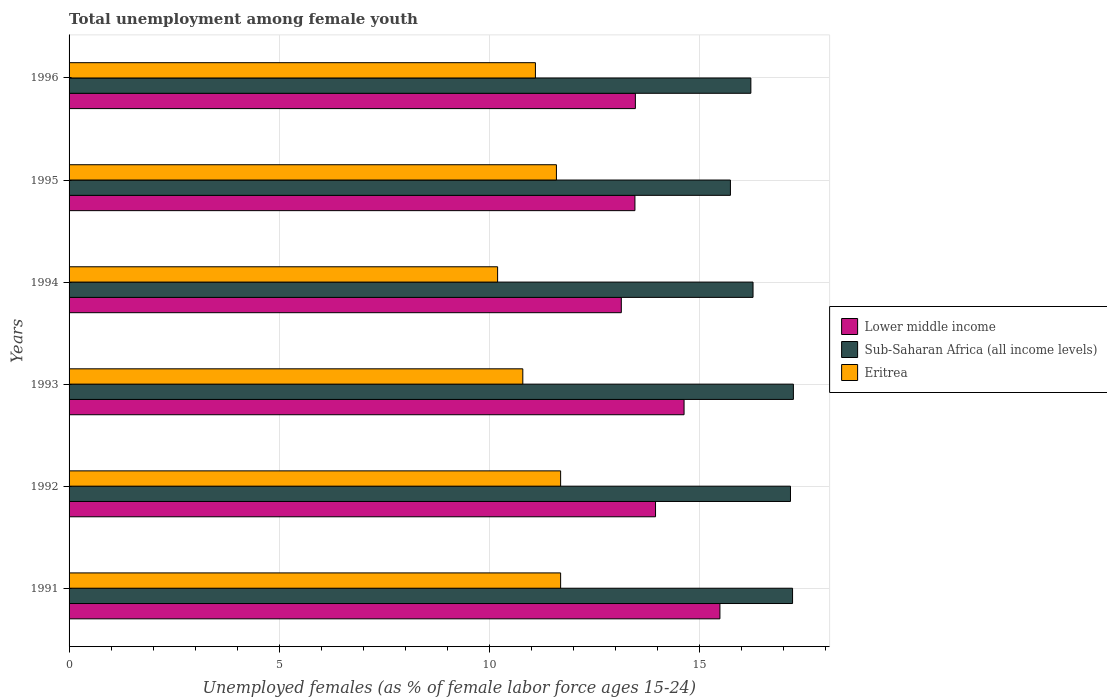How many different coloured bars are there?
Ensure brevity in your answer.  3. How many groups of bars are there?
Make the answer very short. 6. Are the number of bars on each tick of the Y-axis equal?
Provide a succinct answer. Yes. How many bars are there on the 1st tick from the top?
Ensure brevity in your answer.  3. How many bars are there on the 5th tick from the bottom?
Your response must be concise. 3. What is the label of the 4th group of bars from the top?
Offer a terse response. 1993. What is the percentage of unemployed females in in Lower middle income in 1992?
Keep it short and to the point. 13.96. Across all years, what is the maximum percentage of unemployed females in in Eritrea?
Offer a terse response. 11.7. Across all years, what is the minimum percentage of unemployed females in in Eritrea?
Your answer should be very brief. 10.2. In which year was the percentage of unemployed females in in Lower middle income maximum?
Keep it short and to the point. 1991. In which year was the percentage of unemployed females in in Eritrea minimum?
Make the answer very short. 1994. What is the total percentage of unemployed females in in Sub-Saharan Africa (all income levels) in the graph?
Your answer should be compact. 99.88. What is the difference between the percentage of unemployed females in in Eritrea in 1991 and that in 1992?
Offer a terse response. 0. What is the difference between the percentage of unemployed females in in Sub-Saharan Africa (all income levels) in 1993 and the percentage of unemployed females in in Lower middle income in 1992?
Provide a succinct answer. 3.28. What is the average percentage of unemployed females in in Eritrea per year?
Your answer should be compact. 11.18. In the year 1996, what is the difference between the percentage of unemployed females in in Eritrea and percentage of unemployed females in in Lower middle income?
Keep it short and to the point. -2.38. What is the ratio of the percentage of unemployed females in in Lower middle income in 1991 to that in 1994?
Give a very brief answer. 1.18. What is the difference between the highest and the second highest percentage of unemployed females in in Sub-Saharan Africa (all income levels)?
Ensure brevity in your answer.  0.02. What is the difference between the highest and the lowest percentage of unemployed females in in Sub-Saharan Africa (all income levels)?
Offer a terse response. 1.5. What does the 1st bar from the top in 1992 represents?
Offer a very short reply. Eritrea. What does the 1st bar from the bottom in 1992 represents?
Provide a short and direct response. Lower middle income. Is it the case that in every year, the sum of the percentage of unemployed females in in Eritrea and percentage of unemployed females in in Lower middle income is greater than the percentage of unemployed females in in Sub-Saharan Africa (all income levels)?
Offer a very short reply. Yes. How many bars are there?
Provide a short and direct response. 18. Are all the bars in the graph horizontal?
Make the answer very short. Yes. How many years are there in the graph?
Make the answer very short. 6. What is the difference between two consecutive major ticks on the X-axis?
Offer a terse response. 5. Does the graph contain any zero values?
Keep it short and to the point. No. How are the legend labels stacked?
Your response must be concise. Vertical. What is the title of the graph?
Ensure brevity in your answer.  Total unemployment among female youth. What is the label or title of the X-axis?
Give a very brief answer. Unemployed females (as % of female labor force ages 15-24). What is the Unemployed females (as % of female labor force ages 15-24) in Lower middle income in 1991?
Offer a very short reply. 15.49. What is the Unemployed females (as % of female labor force ages 15-24) of Sub-Saharan Africa (all income levels) in 1991?
Give a very brief answer. 17.22. What is the Unemployed females (as % of female labor force ages 15-24) of Eritrea in 1991?
Make the answer very short. 11.7. What is the Unemployed females (as % of female labor force ages 15-24) in Lower middle income in 1992?
Provide a short and direct response. 13.96. What is the Unemployed females (as % of female labor force ages 15-24) in Sub-Saharan Africa (all income levels) in 1992?
Your answer should be very brief. 17.17. What is the Unemployed females (as % of female labor force ages 15-24) in Eritrea in 1992?
Provide a short and direct response. 11.7. What is the Unemployed females (as % of female labor force ages 15-24) of Lower middle income in 1993?
Provide a short and direct response. 14.64. What is the Unemployed females (as % of female labor force ages 15-24) in Sub-Saharan Africa (all income levels) in 1993?
Make the answer very short. 17.24. What is the Unemployed females (as % of female labor force ages 15-24) of Eritrea in 1993?
Your answer should be very brief. 10.8. What is the Unemployed females (as % of female labor force ages 15-24) of Lower middle income in 1994?
Make the answer very short. 13.14. What is the Unemployed females (as % of female labor force ages 15-24) in Sub-Saharan Africa (all income levels) in 1994?
Make the answer very short. 16.28. What is the Unemployed females (as % of female labor force ages 15-24) of Eritrea in 1994?
Your answer should be very brief. 10.2. What is the Unemployed females (as % of female labor force ages 15-24) in Lower middle income in 1995?
Your response must be concise. 13.47. What is the Unemployed females (as % of female labor force ages 15-24) of Sub-Saharan Africa (all income levels) in 1995?
Your response must be concise. 15.74. What is the Unemployed females (as % of female labor force ages 15-24) of Eritrea in 1995?
Keep it short and to the point. 11.6. What is the Unemployed females (as % of female labor force ages 15-24) in Lower middle income in 1996?
Your answer should be very brief. 13.48. What is the Unemployed females (as % of female labor force ages 15-24) in Sub-Saharan Africa (all income levels) in 1996?
Provide a succinct answer. 16.23. What is the Unemployed females (as % of female labor force ages 15-24) in Eritrea in 1996?
Ensure brevity in your answer.  11.1. Across all years, what is the maximum Unemployed females (as % of female labor force ages 15-24) in Lower middle income?
Keep it short and to the point. 15.49. Across all years, what is the maximum Unemployed females (as % of female labor force ages 15-24) in Sub-Saharan Africa (all income levels)?
Give a very brief answer. 17.24. Across all years, what is the maximum Unemployed females (as % of female labor force ages 15-24) of Eritrea?
Offer a very short reply. 11.7. Across all years, what is the minimum Unemployed females (as % of female labor force ages 15-24) in Lower middle income?
Offer a terse response. 13.14. Across all years, what is the minimum Unemployed females (as % of female labor force ages 15-24) of Sub-Saharan Africa (all income levels)?
Offer a very short reply. 15.74. Across all years, what is the minimum Unemployed females (as % of female labor force ages 15-24) in Eritrea?
Offer a terse response. 10.2. What is the total Unemployed females (as % of female labor force ages 15-24) in Lower middle income in the graph?
Give a very brief answer. 84.18. What is the total Unemployed females (as % of female labor force ages 15-24) of Sub-Saharan Africa (all income levels) in the graph?
Your answer should be compact. 99.88. What is the total Unemployed females (as % of female labor force ages 15-24) in Eritrea in the graph?
Offer a very short reply. 67.1. What is the difference between the Unemployed females (as % of female labor force ages 15-24) in Lower middle income in 1991 and that in 1992?
Keep it short and to the point. 1.53. What is the difference between the Unemployed females (as % of female labor force ages 15-24) of Sub-Saharan Africa (all income levels) in 1991 and that in 1992?
Give a very brief answer. 0.05. What is the difference between the Unemployed females (as % of female labor force ages 15-24) in Lower middle income in 1991 and that in 1993?
Your answer should be very brief. 0.85. What is the difference between the Unemployed females (as % of female labor force ages 15-24) of Sub-Saharan Africa (all income levels) in 1991 and that in 1993?
Provide a short and direct response. -0.02. What is the difference between the Unemployed females (as % of female labor force ages 15-24) of Eritrea in 1991 and that in 1993?
Give a very brief answer. 0.9. What is the difference between the Unemployed females (as % of female labor force ages 15-24) of Lower middle income in 1991 and that in 1994?
Give a very brief answer. 2.35. What is the difference between the Unemployed females (as % of female labor force ages 15-24) of Sub-Saharan Africa (all income levels) in 1991 and that in 1994?
Provide a short and direct response. 0.94. What is the difference between the Unemployed females (as % of female labor force ages 15-24) of Eritrea in 1991 and that in 1994?
Your response must be concise. 1.5. What is the difference between the Unemployed females (as % of female labor force ages 15-24) of Lower middle income in 1991 and that in 1995?
Give a very brief answer. 2.02. What is the difference between the Unemployed females (as % of female labor force ages 15-24) of Sub-Saharan Africa (all income levels) in 1991 and that in 1995?
Your answer should be very brief. 1.48. What is the difference between the Unemployed females (as % of female labor force ages 15-24) of Lower middle income in 1991 and that in 1996?
Offer a terse response. 2.01. What is the difference between the Unemployed females (as % of female labor force ages 15-24) in Eritrea in 1991 and that in 1996?
Your answer should be compact. 0.6. What is the difference between the Unemployed females (as % of female labor force ages 15-24) in Lower middle income in 1992 and that in 1993?
Give a very brief answer. -0.68. What is the difference between the Unemployed females (as % of female labor force ages 15-24) in Sub-Saharan Africa (all income levels) in 1992 and that in 1993?
Your response must be concise. -0.07. What is the difference between the Unemployed females (as % of female labor force ages 15-24) of Eritrea in 1992 and that in 1993?
Your answer should be very brief. 0.9. What is the difference between the Unemployed females (as % of female labor force ages 15-24) of Lower middle income in 1992 and that in 1994?
Provide a succinct answer. 0.81. What is the difference between the Unemployed females (as % of female labor force ages 15-24) in Sub-Saharan Africa (all income levels) in 1992 and that in 1994?
Provide a short and direct response. 0.89. What is the difference between the Unemployed females (as % of female labor force ages 15-24) of Eritrea in 1992 and that in 1994?
Offer a very short reply. 1.5. What is the difference between the Unemployed females (as % of female labor force ages 15-24) in Lower middle income in 1992 and that in 1995?
Give a very brief answer. 0.49. What is the difference between the Unemployed females (as % of female labor force ages 15-24) of Sub-Saharan Africa (all income levels) in 1992 and that in 1995?
Provide a short and direct response. 1.43. What is the difference between the Unemployed females (as % of female labor force ages 15-24) of Eritrea in 1992 and that in 1995?
Your answer should be very brief. 0.1. What is the difference between the Unemployed females (as % of female labor force ages 15-24) of Lower middle income in 1992 and that in 1996?
Ensure brevity in your answer.  0.48. What is the difference between the Unemployed females (as % of female labor force ages 15-24) in Sub-Saharan Africa (all income levels) in 1992 and that in 1996?
Keep it short and to the point. 0.94. What is the difference between the Unemployed females (as % of female labor force ages 15-24) of Lower middle income in 1993 and that in 1994?
Make the answer very short. 1.49. What is the difference between the Unemployed females (as % of female labor force ages 15-24) of Sub-Saharan Africa (all income levels) in 1993 and that in 1994?
Ensure brevity in your answer.  0.96. What is the difference between the Unemployed females (as % of female labor force ages 15-24) of Eritrea in 1993 and that in 1994?
Keep it short and to the point. 0.6. What is the difference between the Unemployed females (as % of female labor force ages 15-24) in Lower middle income in 1993 and that in 1995?
Keep it short and to the point. 1.17. What is the difference between the Unemployed females (as % of female labor force ages 15-24) in Sub-Saharan Africa (all income levels) in 1993 and that in 1995?
Your answer should be very brief. 1.5. What is the difference between the Unemployed females (as % of female labor force ages 15-24) of Eritrea in 1993 and that in 1995?
Your answer should be very brief. -0.8. What is the difference between the Unemployed females (as % of female labor force ages 15-24) in Lower middle income in 1993 and that in 1996?
Your answer should be very brief. 1.16. What is the difference between the Unemployed females (as % of female labor force ages 15-24) in Sub-Saharan Africa (all income levels) in 1993 and that in 1996?
Your response must be concise. 1.01. What is the difference between the Unemployed females (as % of female labor force ages 15-24) in Lower middle income in 1994 and that in 1995?
Keep it short and to the point. -0.32. What is the difference between the Unemployed females (as % of female labor force ages 15-24) of Sub-Saharan Africa (all income levels) in 1994 and that in 1995?
Your answer should be very brief. 0.54. What is the difference between the Unemployed females (as % of female labor force ages 15-24) in Eritrea in 1994 and that in 1995?
Provide a short and direct response. -1.4. What is the difference between the Unemployed females (as % of female labor force ages 15-24) in Lower middle income in 1994 and that in 1996?
Give a very brief answer. -0.33. What is the difference between the Unemployed females (as % of female labor force ages 15-24) in Sub-Saharan Africa (all income levels) in 1994 and that in 1996?
Ensure brevity in your answer.  0.05. What is the difference between the Unemployed females (as % of female labor force ages 15-24) in Eritrea in 1994 and that in 1996?
Provide a short and direct response. -0.9. What is the difference between the Unemployed females (as % of female labor force ages 15-24) of Lower middle income in 1995 and that in 1996?
Give a very brief answer. -0.01. What is the difference between the Unemployed females (as % of female labor force ages 15-24) of Sub-Saharan Africa (all income levels) in 1995 and that in 1996?
Ensure brevity in your answer.  -0.49. What is the difference between the Unemployed females (as % of female labor force ages 15-24) in Eritrea in 1995 and that in 1996?
Provide a short and direct response. 0.5. What is the difference between the Unemployed females (as % of female labor force ages 15-24) in Lower middle income in 1991 and the Unemployed females (as % of female labor force ages 15-24) in Sub-Saharan Africa (all income levels) in 1992?
Keep it short and to the point. -1.68. What is the difference between the Unemployed females (as % of female labor force ages 15-24) of Lower middle income in 1991 and the Unemployed females (as % of female labor force ages 15-24) of Eritrea in 1992?
Make the answer very short. 3.79. What is the difference between the Unemployed females (as % of female labor force ages 15-24) of Sub-Saharan Africa (all income levels) in 1991 and the Unemployed females (as % of female labor force ages 15-24) of Eritrea in 1992?
Give a very brief answer. 5.52. What is the difference between the Unemployed females (as % of female labor force ages 15-24) of Lower middle income in 1991 and the Unemployed females (as % of female labor force ages 15-24) of Sub-Saharan Africa (all income levels) in 1993?
Offer a very short reply. -1.75. What is the difference between the Unemployed females (as % of female labor force ages 15-24) in Lower middle income in 1991 and the Unemployed females (as % of female labor force ages 15-24) in Eritrea in 1993?
Provide a succinct answer. 4.69. What is the difference between the Unemployed females (as % of female labor force ages 15-24) of Sub-Saharan Africa (all income levels) in 1991 and the Unemployed females (as % of female labor force ages 15-24) of Eritrea in 1993?
Your answer should be very brief. 6.42. What is the difference between the Unemployed females (as % of female labor force ages 15-24) of Lower middle income in 1991 and the Unemployed females (as % of female labor force ages 15-24) of Sub-Saharan Africa (all income levels) in 1994?
Give a very brief answer. -0.79. What is the difference between the Unemployed females (as % of female labor force ages 15-24) in Lower middle income in 1991 and the Unemployed females (as % of female labor force ages 15-24) in Eritrea in 1994?
Make the answer very short. 5.29. What is the difference between the Unemployed females (as % of female labor force ages 15-24) of Sub-Saharan Africa (all income levels) in 1991 and the Unemployed females (as % of female labor force ages 15-24) of Eritrea in 1994?
Your answer should be very brief. 7.02. What is the difference between the Unemployed females (as % of female labor force ages 15-24) in Lower middle income in 1991 and the Unemployed females (as % of female labor force ages 15-24) in Sub-Saharan Africa (all income levels) in 1995?
Your response must be concise. -0.25. What is the difference between the Unemployed females (as % of female labor force ages 15-24) of Lower middle income in 1991 and the Unemployed females (as % of female labor force ages 15-24) of Eritrea in 1995?
Ensure brevity in your answer.  3.89. What is the difference between the Unemployed females (as % of female labor force ages 15-24) of Sub-Saharan Africa (all income levels) in 1991 and the Unemployed females (as % of female labor force ages 15-24) of Eritrea in 1995?
Offer a very short reply. 5.62. What is the difference between the Unemployed females (as % of female labor force ages 15-24) of Lower middle income in 1991 and the Unemployed females (as % of female labor force ages 15-24) of Sub-Saharan Africa (all income levels) in 1996?
Your response must be concise. -0.74. What is the difference between the Unemployed females (as % of female labor force ages 15-24) of Lower middle income in 1991 and the Unemployed females (as % of female labor force ages 15-24) of Eritrea in 1996?
Your answer should be compact. 4.39. What is the difference between the Unemployed females (as % of female labor force ages 15-24) of Sub-Saharan Africa (all income levels) in 1991 and the Unemployed females (as % of female labor force ages 15-24) of Eritrea in 1996?
Your answer should be very brief. 6.12. What is the difference between the Unemployed females (as % of female labor force ages 15-24) of Lower middle income in 1992 and the Unemployed females (as % of female labor force ages 15-24) of Sub-Saharan Africa (all income levels) in 1993?
Keep it short and to the point. -3.28. What is the difference between the Unemployed females (as % of female labor force ages 15-24) of Lower middle income in 1992 and the Unemployed females (as % of female labor force ages 15-24) of Eritrea in 1993?
Keep it short and to the point. 3.16. What is the difference between the Unemployed females (as % of female labor force ages 15-24) of Sub-Saharan Africa (all income levels) in 1992 and the Unemployed females (as % of female labor force ages 15-24) of Eritrea in 1993?
Give a very brief answer. 6.37. What is the difference between the Unemployed females (as % of female labor force ages 15-24) in Lower middle income in 1992 and the Unemployed females (as % of female labor force ages 15-24) in Sub-Saharan Africa (all income levels) in 1994?
Make the answer very short. -2.32. What is the difference between the Unemployed females (as % of female labor force ages 15-24) in Lower middle income in 1992 and the Unemployed females (as % of female labor force ages 15-24) in Eritrea in 1994?
Provide a short and direct response. 3.76. What is the difference between the Unemployed females (as % of female labor force ages 15-24) in Sub-Saharan Africa (all income levels) in 1992 and the Unemployed females (as % of female labor force ages 15-24) in Eritrea in 1994?
Ensure brevity in your answer.  6.97. What is the difference between the Unemployed females (as % of female labor force ages 15-24) in Lower middle income in 1992 and the Unemployed females (as % of female labor force ages 15-24) in Sub-Saharan Africa (all income levels) in 1995?
Provide a succinct answer. -1.78. What is the difference between the Unemployed females (as % of female labor force ages 15-24) of Lower middle income in 1992 and the Unemployed females (as % of female labor force ages 15-24) of Eritrea in 1995?
Give a very brief answer. 2.36. What is the difference between the Unemployed females (as % of female labor force ages 15-24) of Sub-Saharan Africa (all income levels) in 1992 and the Unemployed females (as % of female labor force ages 15-24) of Eritrea in 1995?
Offer a terse response. 5.57. What is the difference between the Unemployed females (as % of female labor force ages 15-24) in Lower middle income in 1992 and the Unemployed females (as % of female labor force ages 15-24) in Sub-Saharan Africa (all income levels) in 1996?
Offer a terse response. -2.27. What is the difference between the Unemployed females (as % of female labor force ages 15-24) of Lower middle income in 1992 and the Unemployed females (as % of female labor force ages 15-24) of Eritrea in 1996?
Give a very brief answer. 2.86. What is the difference between the Unemployed females (as % of female labor force ages 15-24) of Sub-Saharan Africa (all income levels) in 1992 and the Unemployed females (as % of female labor force ages 15-24) of Eritrea in 1996?
Make the answer very short. 6.07. What is the difference between the Unemployed females (as % of female labor force ages 15-24) of Lower middle income in 1993 and the Unemployed females (as % of female labor force ages 15-24) of Sub-Saharan Africa (all income levels) in 1994?
Provide a succinct answer. -1.64. What is the difference between the Unemployed females (as % of female labor force ages 15-24) in Lower middle income in 1993 and the Unemployed females (as % of female labor force ages 15-24) in Eritrea in 1994?
Provide a short and direct response. 4.44. What is the difference between the Unemployed females (as % of female labor force ages 15-24) in Sub-Saharan Africa (all income levels) in 1993 and the Unemployed females (as % of female labor force ages 15-24) in Eritrea in 1994?
Provide a succinct answer. 7.04. What is the difference between the Unemployed females (as % of female labor force ages 15-24) of Lower middle income in 1993 and the Unemployed females (as % of female labor force ages 15-24) of Sub-Saharan Africa (all income levels) in 1995?
Give a very brief answer. -1.1. What is the difference between the Unemployed females (as % of female labor force ages 15-24) in Lower middle income in 1993 and the Unemployed females (as % of female labor force ages 15-24) in Eritrea in 1995?
Your answer should be very brief. 3.04. What is the difference between the Unemployed females (as % of female labor force ages 15-24) of Sub-Saharan Africa (all income levels) in 1993 and the Unemployed females (as % of female labor force ages 15-24) of Eritrea in 1995?
Give a very brief answer. 5.64. What is the difference between the Unemployed females (as % of female labor force ages 15-24) of Lower middle income in 1993 and the Unemployed females (as % of female labor force ages 15-24) of Sub-Saharan Africa (all income levels) in 1996?
Give a very brief answer. -1.59. What is the difference between the Unemployed females (as % of female labor force ages 15-24) of Lower middle income in 1993 and the Unemployed females (as % of female labor force ages 15-24) of Eritrea in 1996?
Give a very brief answer. 3.54. What is the difference between the Unemployed females (as % of female labor force ages 15-24) of Sub-Saharan Africa (all income levels) in 1993 and the Unemployed females (as % of female labor force ages 15-24) of Eritrea in 1996?
Make the answer very short. 6.14. What is the difference between the Unemployed females (as % of female labor force ages 15-24) in Lower middle income in 1994 and the Unemployed females (as % of female labor force ages 15-24) in Sub-Saharan Africa (all income levels) in 1995?
Your answer should be compact. -2.6. What is the difference between the Unemployed females (as % of female labor force ages 15-24) of Lower middle income in 1994 and the Unemployed females (as % of female labor force ages 15-24) of Eritrea in 1995?
Keep it short and to the point. 1.54. What is the difference between the Unemployed females (as % of female labor force ages 15-24) of Sub-Saharan Africa (all income levels) in 1994 and the Unemployed females (as % of female labor force ages 15-24) of Eritrea in 1995?
Keep it short and to the point. 4.68. What is the difference between the Unemployed females (as % of female labor force ages 15-24) in Lower middle income in 1994 and the Unemployed females (as % of female labor force ages 15-24) in Sub-Saharan Africa (all income levels) in 1996?
Your answer should be compact. -3.08. What is the difference between the Unemployed females (as % of female labor force ages 15-24) of Lower middle income in 1994 and the Unemployed females (as % of female labor force ages 15-24) of Eritrea in 1996?
Offer a very short reply. 2.04. What is the difference between the Unemployed females (as % of female labor force ages 15-24) in Sub-Saharan Africa (all income levels) in 1994 and the Unemployed females (as % of female labor force ages 15-24) in Eritrea in 1996?
Ensure brevity in your answer.  5.18. What is the difference between the Unemployed females (as % of female labor force ages 15-24) in Lower middle income in 1995 and the Unemployed females (as % of female labor force ages 15-24) in Sub-Saharan Africa (all income levels) in 1996?
Ensure brevity in your answer.  -2.76. What is the difference between the Unemployed females (as % of female labor force ages 15-24) in Lower middle income in 1995 and the Unemployed females (as % of female labor force ages 15-24) in Eritrea in 1996?
Offer a very short reply. 2.37. What is the difference between the Unemployed females (as % of female labor force ages 15-24) in Sub-Saharan Africa (all income levels) in 1995 and the Unemployed females (as % of female labor force ages 15-24) in Eritrea in 1996?
Your response must be concise. 4.64. What is the average Unemployed females (as % of female labor force ages 15-24) in Lower middle income per year?
Ensure brevity in your answer.  14.03. What is the average Unemployed females (as % of female labor force ages 15-24) in Sub-Saharan Africa (all income levels) per year?
Provide a short and direct response. 16.65. What is the average Unemployed females (as % of female labor force ages 15-24) in Eritrea per year?
Your response must be concise. 11.18. In the year 1991, what is the difference between the Unemployed females (as % of female labor force ages 15-24) in Lower middle income and Unemployed females (as % of female labor force ages 15-24) in Sub-Saharan Africa (all income levels)?
Give a very brief answer. -1.73. In the year 1991, what is the difference between the Unemployed females (as % of female labor force ages 15-24) of Lower middle income and Unemployed females (as % of female labor force ages 15-24) of Eritrea?
Offer a terse response. 3.79. In the year 1991, what is the difference between the Unemployed females (as % of female labor force ages 15-24) of Sub-Saharan Africa (all income levels) and Unemployed females (as % of female labor force ages 15-24) of Eritrea?
Your answer should be very brief. 5.52. In the year 1992, what is the difference between the Unemployed females (as % of female labor force ages 15-24) in Lower middle income and Unemployed females (as % of female labor force ages 15-24) in Sub-Saharan Africa (all income levels)?
Give a very brief answer. -3.21. In the year 1992, what is the difference between the Unemployed females (as % of female labor force ages 15-24) of Lower middle income and Unemployed females (as % of female labor force ages 15-24) of Eritrea?
Your response must be concise. 2.26. In the year 1992, what is the difference between the Unemployed females (as % of female labor force ages 15-24) of Sub-Saharan Africa (all income levels) and Unemployed females (as % of female labor force ages 15-24) of Eritrea?
Provide a succinct answer. 5.47. In the year 1993, what is the difference between the Unemployed females (as % of female labor force ages 15-24) of Lower middle income and Unemployed females (as % of female labor force ages 15-24) of Sub-Saharan Africa (all income levels)?
Offer a terse response. -2.6. In the year 1993, what is the difference between the Unemployed females (as % of female labor force ages 15-24) of Lower middle income and Unemployed females (as % of female labor force ages 15-24) of Eritrea?
Your response must be concise. 3.84. In the year 1993, what is the difference between the Unemployed females (as % of female labor force ages 15-24) of Sub-Saharan Africa (all income levels) and Unemployed females (as % of female labor force ages 15-24) of Eritrea?
Your answer should be compact. 6.44. In the year 1994, what is the difference between the Unemployed females (as % of female labor force ages 15-24) of Lower middle income and Unemployed females (as % of female labor force ages 15-24) of Sub-Saharan Africa (all income levels)?
Offer a terse response. -3.14. In the year 1994, what is the difference between the Unemployed females (as % of female labor force ages 15-24) of Lower middle income and Unemployed females (as % of female labor force ages 15-24) of Eritrea?
Provide a succinct answer. 2.94. In the year 1994, what is the difference between the Unemployed females (as % of female labor force ages 15-24) in Sub-Saharan Africa (all income levels) and Unemployed females (as % of female labor force ages 15-24) in Eritrea?
Provide a succinct answer. 6.08. In the year 1995, what is the difference between the Unemployed females (as % of female labor force ages 15-24) in Lower middle income and Unemployed females (as % of female labor force ages 15-24) in Sub-Saharan Africa (all income levels)?
Provide a short and direct response. -2.27. In the year 1995, what is the difference between the Unemployed females (as % of female labor force ages 15-24) of Lower middle income and Unemployed females (as % of female labor force ages 15-24) of Eritrea?
Give a very brief answer. 1.87. In the year 1995, what is the difference between the Unemployed females (as % of female labor force ages 15-24) in Sub-Saharan Africa (all income levels) and Unemployed females (as % of female labor force ages 15-24) in Eritrea?
Provide a succinct answer. 4.14. In the year 1996, what is the difference between the Unemployed females (as % of female labor force ages 15-24) of Lower middle income and Unemployed females (as % of female labor force ages 15-24) of Sub-Saharan Africa (all income levels)?
Offer a terse response. -2.75. In the year 1996, what is the difference between the Unemployed females (as % of female labor force ages 15-24) of Lower middle income and Unemployed females (as % of female labor force ages 15-24) of Eritrea?
Your response must be concise. 2.38. In the year 1996, what is the difference between the Unemployed females (as % of female labor force ages 15-24) of Sub-Saharan Africa (all income levels) and Unemployed females (as % of female labor force ages 15-24) of Eritrea?
Offer a very short reply. 5.13. What is the ratio of the Unemployed females (as % of female labor force ages 15-24) of Lower middle income in 1991 to that in 1992?
Give a very brief answer. 1.11. What is the ratio of the Unemployed females (as % of female labor force ages 15-24) of Sub-Saharan Africa (all income levels) in 1991 to that in 1992?
Provide a short and direct response. 1. What is the ratio of the Unemployed females (as % of female labor force ages 15-24) of Eritrea in 1991 to that in 1992?
Give a very brief answer. 1. What is the ratio of the Unemployed females (as % of female labor force ages 15-24) of Lower middle income in 1991 to that in 1993?
Keep it short and to the point. 1.06. What is the ratio of the Unemployed females (as % of female labor force ages 15-24) of Eritrea in 1991 to that in 1993?
Make the answer very short. 1.08. What is the ratio of the Unemployed females (as % of female labor force ages 15-24) in Lower middle income in 1991 to that in 1994?
Provide a short and direct response. 1.18. What is the ratio of the Unemployed females (as % of female labor force ages 15-24) of Sub-Saharan Africa (all income levels) in 1991 to that in 1994?
Provide a succinct answer. 1.06. What is the ratio of the Unemployed females (as % of female labor force ages 15-24) of Eritrea in 1991 to that in 1994?
Provide a succinct answer. 1.15. What is the ratio of the Unemployed females (as % of female labor force ages 15-24) of Lower middle income in 1991 to that in 1995?
Ensure brevity in your answer.  1.15. What is the ratio of the Unemployed females (as % of female labor force ages 15-24) of Sub-Saharan Africa (all income levels) in 1991 to that in 1995?
Provide a succinct answer. 1.09. What is the ratio of the Unemployed females (as % of female labor force ages 15-24) of Eritrea in 1991 to that in 1995?
Ensure brevity in your answer.  1.01. What is the ratio of the Unemployed females (as % of female labor force ages 15-24) in Lower middle income in 1991 to that in 1996?
Your answer should be very brief. 1.15. What is the ratio of the Unemployed females (as % of female labor force ages 15-24) in Sub-Saharan Africa (all income levels) in 1991 to that in 1996?
Keep it short and to the point. 1.06. What is the ratio of the Unemployed females (as % of female labor force ages 15-24) of Eritrea in 1991 to that in 1996?
Make the answer very short. 1.05. What is the ratio of the Unemployed females (as % of female labor force ages 15-24) of Lower middle income in 1992 to that in 1993?
Ensure brevity in your answer.  0.95. What is the ratio of the Unemployed females (as % of female labor force ages 15-24) in Sub-Saharan Africa (all income levels) in 1992 to that in 1993?
Your response must be concise. 1. What is the ratio of the Unemployed females (as % of female labor force ages 15-24) in Eritrea in 1992 to that in 1993?
Offer a very short reply. 1.08. What is the ratio of the Unemployed females (as % of female labor force ages 15-24) of Lower middle income in 1992 to that in 1994?
Your response must be concise. 1.06. What is the ratio of the Unemployed females (as % of female labor force ages 15-24) of Sub-Saharan Africa (all income levels) in 1992 to that in 1994?
Offer a very short reply. 1.05. What is the ratio of the Unemployed females (as % of female labor force ages 15-24) of Eritrea in 1992 to that in 1994?
Offer a terse response. 1.15. What is the ratio of the Unemployed females (as % of female labor force ages 15-24) of Lower middle income in 1992 to that in 1995?
Your response must be concise. 1.04. What is the ratio of the Unemployed females (as % of female labor force ages 15-24) of Sub-Saharan Africa (all income levels) in 1992 to that in 1995?
Ensure brevity in your answer.  1.09. What is the ratio of the Unemployed females (as % of female labor force ages 15-24) of Eritrea in 1992 to that in 1995?
Offer a very short reply. 1.01. What is the ratio of the Unemployed females (as % of female labor force ages 15-24) in Lower middle income in 1992 to that in 1996?
Provide a short and direct response. 1.04. What is the ratio of the Unemployed females (as % of female labor force ages 15-24) of Sub-Saharan Africa (all income levels) in 1992 to that in 1996?
Make the answer very short. 1.06. What is the ratio of the Unemployed females (as % of female labor force ages 15-24) in Eritrea in 1992 to that in 1996?
Give a very brief answer. 1.05. What is the ratio of the Unemployed females (as % of female labor force ages 15-24) in Lower middle income in 1993 to that in 1994?
Offer a very short reply. 1.11. What is the ratio of the Unemployed females (as % of female labor force ages 15-24) in Sub-Saharan Africa (all income levels) in 1993 to that in 1994?
Your response must be concise. 1.06. What is the ratio of the Unemployed females (as % of female labor force ages 15-24) of Eritrea in 1993 to that in 1994?
Offer a very short reply. 1.06. What is the ratio of the Unemployed females (as % of female labor force ages 15-24) of Lower middle income in 1993 to that in 1995?
Your answer should be compact. 1.09. What is the ratio of the Unemployed females (as % of female labor force ages 15-24) in Sub-Saharan Africa (all income levels) in 1993 to that in 1995?
Your answer should be compact. 1.1. What is the ratio of the Unemployed females (as % of female labor force ages 15-24) in Eritrea in 1993 to that in 1995?
Your response must be concise. 0.93. What is the ratio of the Unemployed females (as % of female labor force ages 15-24) in Lower middle income in 1993 to that in 1996?
Give a very brief answer. 1.09. What is the ratio of the Unemployed females (as % of female labor force ages 15-24) of Sub-Saharan Africa (all income levels) in 1993 to that in 1996?
Your answer should be very brief. 1.06. What is the ratio of the Unemployed females (as % of female labor force ages 15-24) of Eritrea in 1993 to that in 1996?
Offer a very short reply. 0.97. What is the ratio of the Unemployed females (as % of female labor force ages 15-24) of Lower middle income in 1994 to that in 1995?
Keep it short and to the point. 0.98. What is the ratio of the Unemployed females (as % of female labor force ages 15-24) of Sub-Saharan Africa (all income levels) in 1994 to that in 1995?
Your response must be concise. 1.03. What is the ratio of the Unemployed females (as % of female labor force ages 15-24) in Eritrea in 1994 to that in 1995?
Keep it short and to the point. 0.88. What is the ratio of the Unemployed females (as % of female labor force ages 15-24) of Lower middle income in 1994 to that in 1996?
Keep it short and to the point. 0.98. What is the ratio of the Unemployed females (as % of female labor force ages 15-24) in Eritrea in 1994 to that in 1996?
Your answer should be compact. 0.92. What is the ratio of the Unemployed females (as % of female labor force ages 15-24) of Sub-Saharan Africa (all income levels) in 1995 to that in 1996?
Offer a terse response. 0.97. What is the ratio of the Unemployed females (as % of female labor force ages 15-24) of Eritrea in 1995 to that in 1996?
Your response must be concise. 1.04. What is the difference between the highest and the second highest Unemployed females (as % of female labor force ages 15-24) in Lower middle income?
Ensure brevity in your answer.  0.85. What is the difference between the highest and the second highest Unemployed females (as % of female labor force ages 15-24) of Sub-Saharan Africa (all income levels)?
Your answer should be very brief. 0.02. What is the difference between the highest and the second highest Unemployed females (as % of female labor force ages 15-24) of Eritrea?
Make the answer very short. 0. What is the difference between the highest and the lowest Unemployed females (as % of female labor force ages 15-24) of Lower middle income?
Provide a succinct answer. 2.35. What is the difference between the highest and the lowest Unemployed females (as % of female labor force ages 15-24) of Sub-Saharan Africa (all income levels)?
Ensure brevity in your answer.  1.5. What is the difference between the highest and the lowest Unemployed females (as % of female labor force ages 15-24) in Eritrea?
Your answer should be very brief. 1.5. 